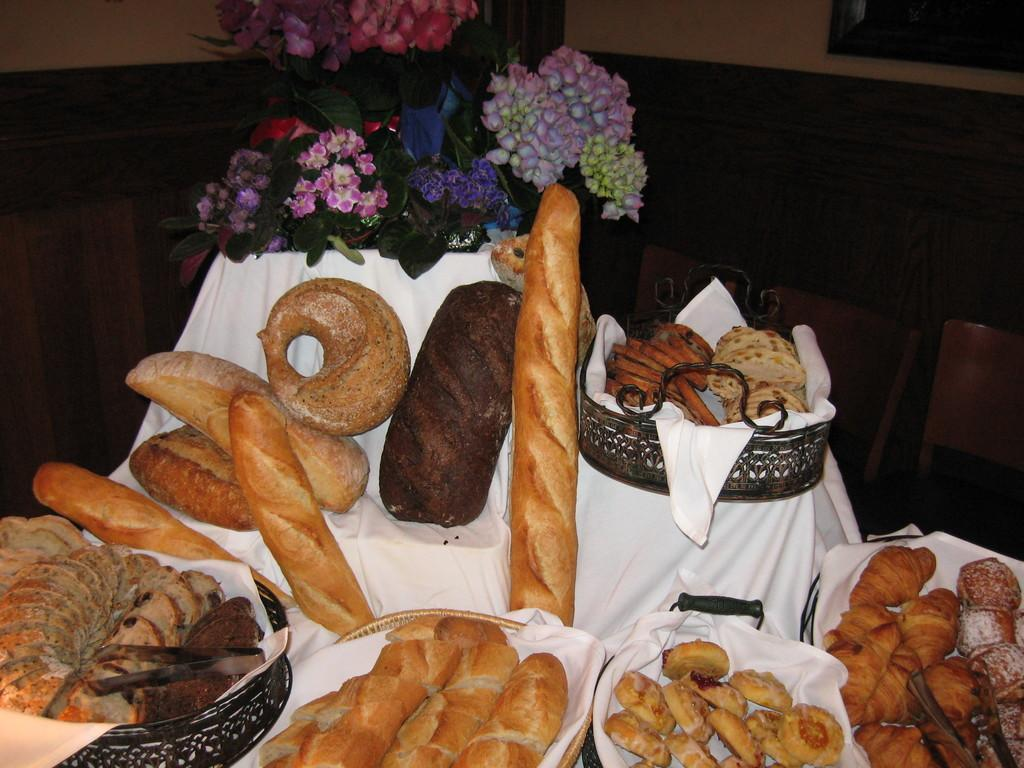What type of food can be seen in the image? The food in the image is in cream and brown colors. How is the food arranged or contained in the image? The food is in a basket. What can be seen in the background of the image? There are multi-color flowers in the background of the image. What is the color of the wall in the background? The wall in the background is in brown and cream colors. How do the bikes cause trouble in the image? There are no bikes present in the image. 